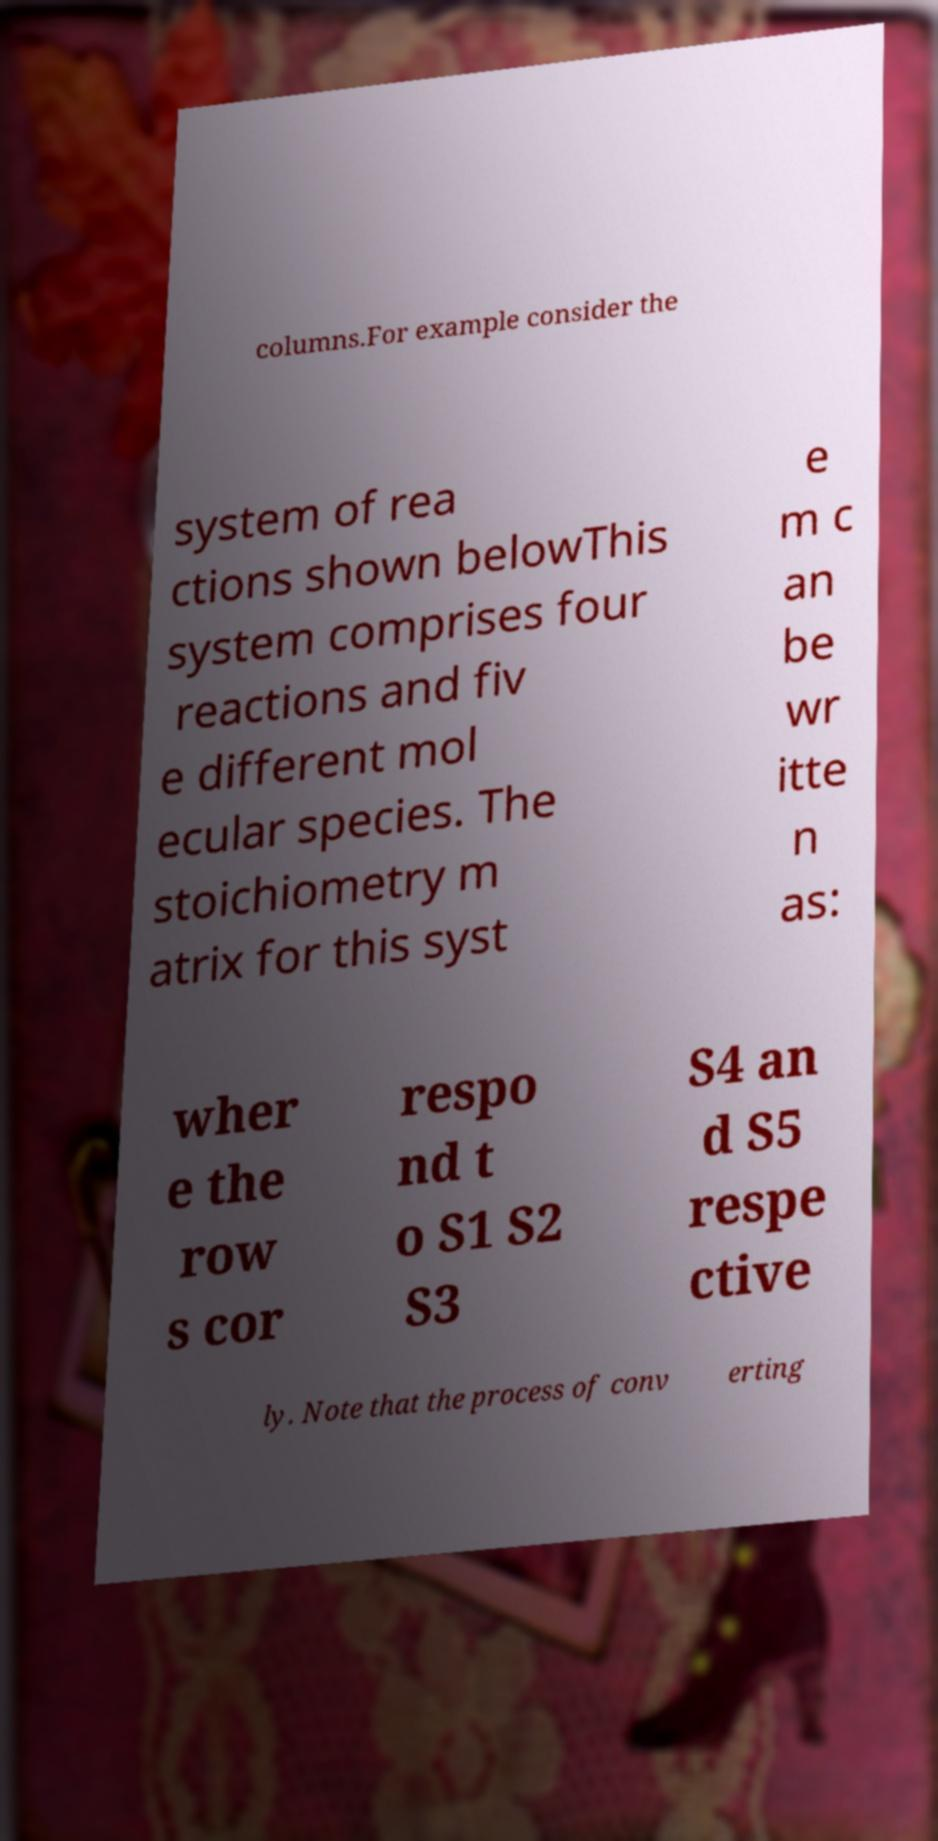Please identify and transcribe the text found in this image. columns.For example consider the system of rea ctions shown belowThis system comprises four reactions and fiv e different mol ecular species. The stoichiometry m atrix for this syst e m c an be wr itte n as: wher e the row s cor respo nd t o S1 S2 S3 S4 an d S5 respe ctive ly. Note that the process of conv erting 